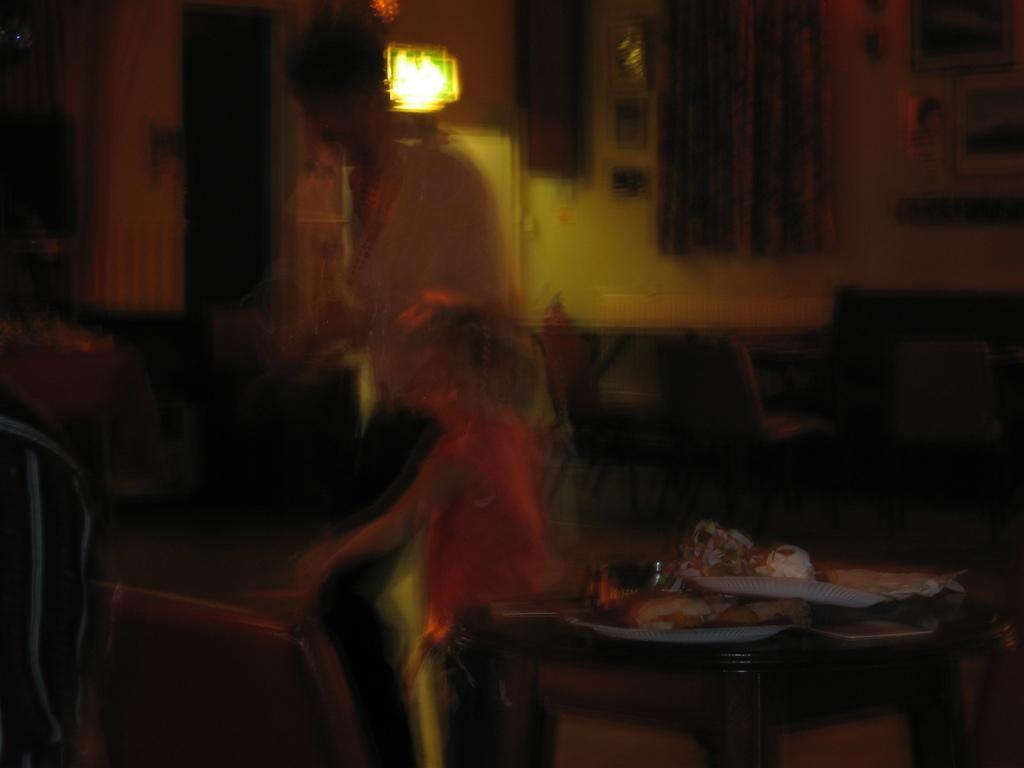Could you give a brief overview of what you see in this image? This image is little blurry but we can see 2 persons here,a woman and a kid. And here there is a table. In the background we can see a light here. On the left there is a person. 